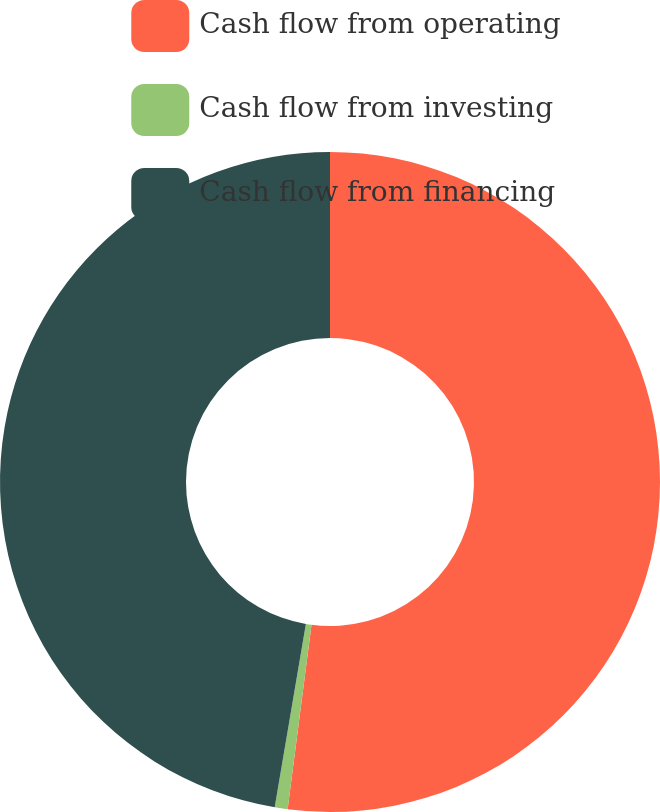Convert chart to OTSL. <chart><loc_0><loc_0><loc_500><loc_500><pie_chart><fcel>Cash flow from operating<fcel>Cash flow from investing<fcel>Cash flow from financing<nl><fcel>52.05%<fcel>0.63%<fcel>47.32%<nl></chart> 